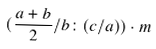<formula> <loc_0><loc_0><loc_500><loc_500>( \frac { a + b } { 2 } / b \colon ( c / a ) ) \cdot m</formula> 